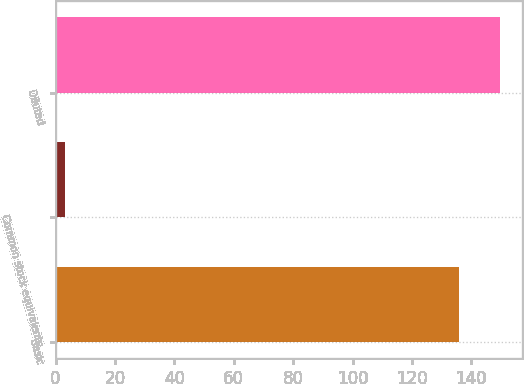Convert chart to OTSL. <chart><loc_0><loc_0><loc_500><loc_500><bar_chart><fcel>Basic<fcel>Common stock equivalents<fcel>Diluted<nl><fcel>135.9<fcel>3.2<fcel>149.49<nl></chart> 